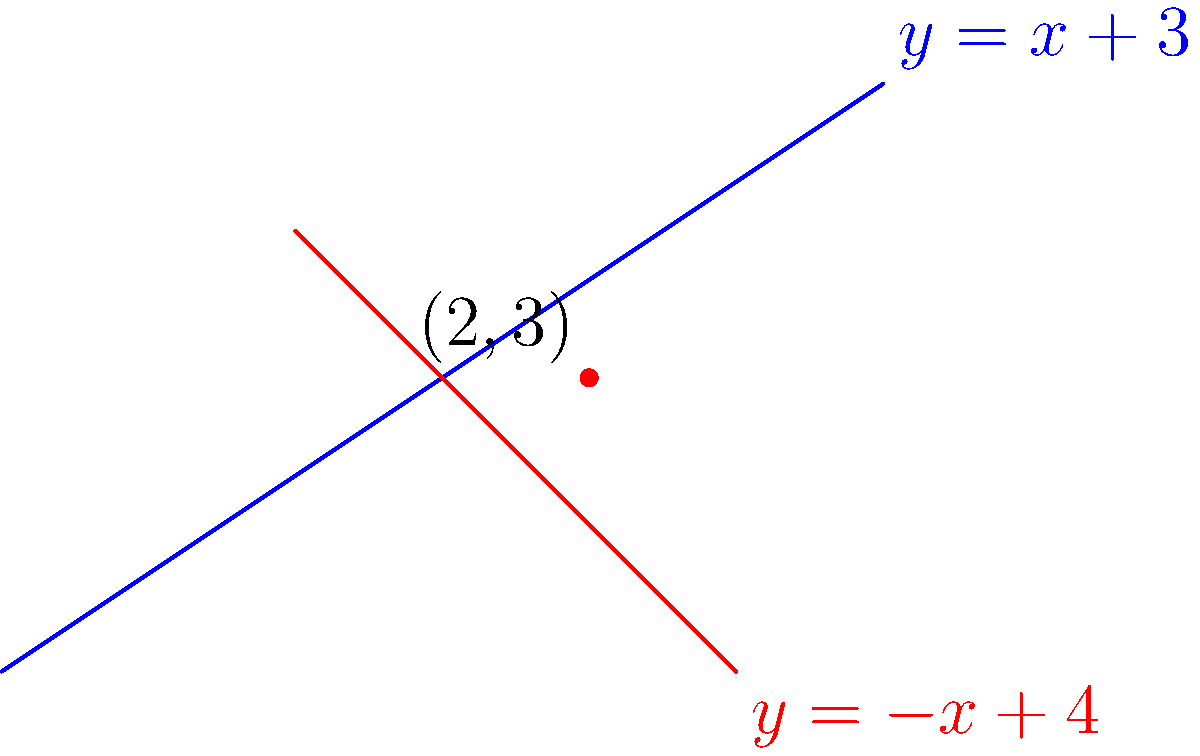In the context of urban planning for a growing Nigerian city, two proposed road expansions are represented by the following equations:

Road A: $y = x + 3$
Road B: $y = -x + 4$

As a student interested in politics and social impact, determine the intersection point of these two roads. How might this intersection point influence the city's development and traffic flow? To find the intersection point, we need to solve the system of equations:

1) First, set the two equations equal to each other:
   $x + 3 = -x + 4$

2) Solve for x:
   $x + 3 = -x + 4$
   $2x = 1$
   $x = \frac{1}{2} = 0.5$

3) Substitute this x-value into either of the original equations. Let's use $y = x + 3$:
   $y = 0.5 + 3 = 3.5$

4) Therefore, the intersection point is $(0.5, 3.5)$

5) However, for practical urban planning purposes, we might round this to whole numbers: $(1, 4)$ or $(0, 3)$, depending on the scale and precision needed.

6) In the context of urban planning:
   - This intersection point could become a major junction in the city.
   - It might be a suitable location for traffic lights, a roundabout, or even an overpass.
   - The area around this intersection could develop into a commercial hub due to increased accessibility.
   - Traffic flow patterns would need to be carefully managed at this point to prevent congestion.
Answer: $(0.5, 3.5)$, rounded to $(1, 4)$ for practical urban planning. 